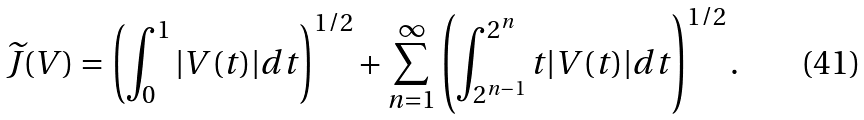Convert formula to latex. <formula><loc_0><loc_0><loc_500><loc_500>\widetilde { J } ( V ) = \left ( \int _ { 0 } ^ { 1 } | V ( t ) | d t \right ) ^ { 1 / 2 } + \sum _ { n = 1 } ^ { \infty } \left ( \int _ { 2 ^ { n - 1 } } ^ { 2 ^ { n } } t | V ( t ) | d t \right ) ^ { 1 / 2 } .</formula> 